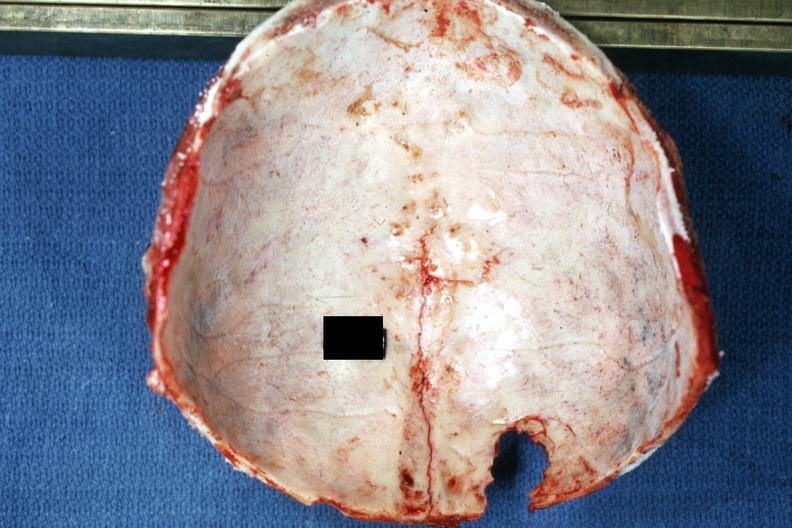does endocrine show easily seen lesion extending up midline to vertex?
Answer the question using a single word or phrase. No 